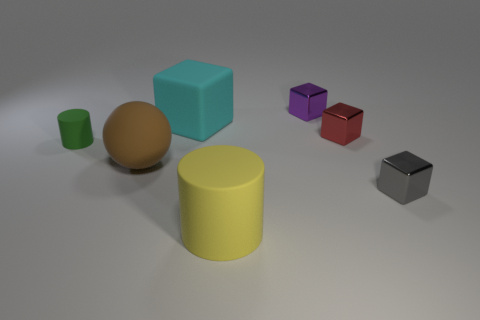There is a tiny gray block; how many cyan blocks are behind it?
Offer a terse response. 1. Are there any red rubber blocks of the same size as the red shiny block?
Make the answer very short. No. There is a matte thing left of the brown matte ball; is its shape the same as the big yellow thing?
Ensure brevity in your answer.  Yes. The matte sphere has what color?
Offer a very short reply. Brown. Are any brown metallic things visible?
Provide a succinct answer. No. There is a cyan block that is the same material as the tiny cylinder; what size is it?
Your answer should be very brief. Large. What is the shape of the small shiny object in front of the small thing on the left side of the small metal block to the left of the tiny red object?
Provide a short and direct response. Cube. Is the number of brown rubber objects that are in front of the small gray metal thing the same as the number of gray matte blocks?
Your response must be concise. Yes. Is the cyan rubber object the same shape as the small red shiny thing?
Make the answer very short. Yes. What number of objects are either small metallic things behind the gray cube or gray metallic cylinders?
Your answer should be compact. 2. 